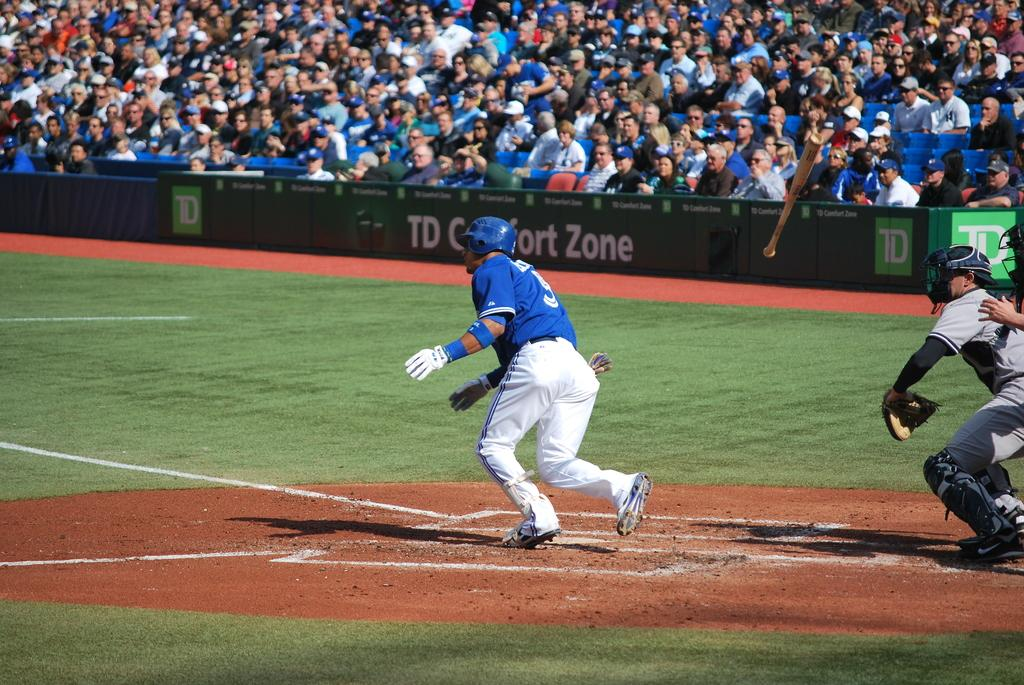<image>
Share a concise interpretation of the image provided. A baseball player at a packed stadium is running toward first base by a sign that says Comfort Zone. 